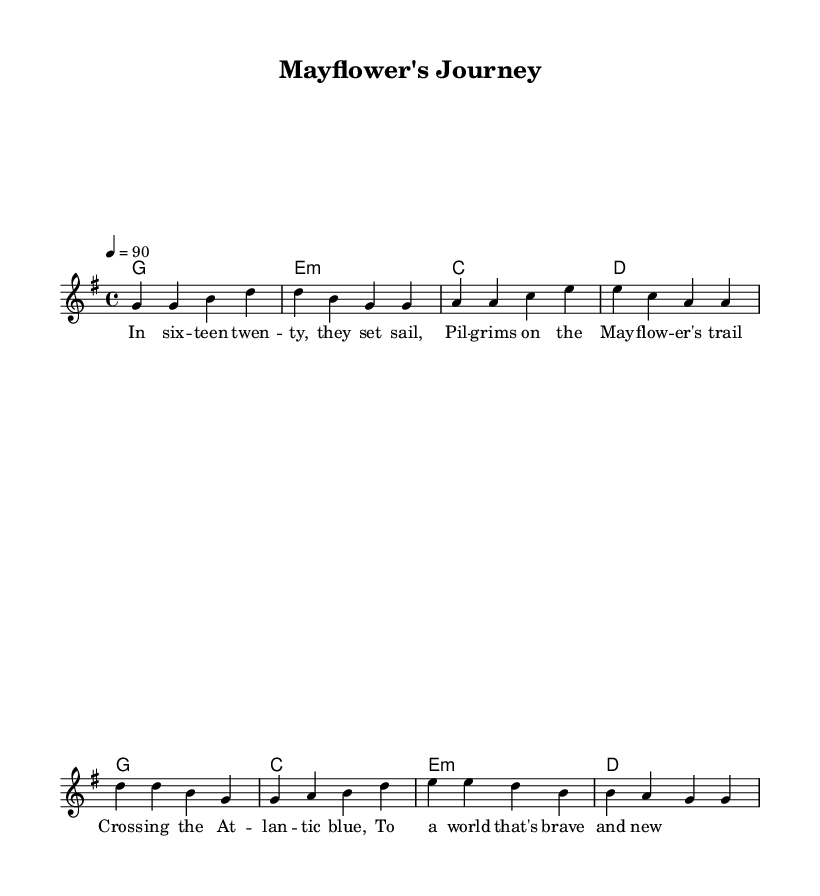What is the key signature of this music? The key signature is G major, which has one sharp (F#).
Answer: G major What is the time signature of this music? The time signature is 4/4, indicating four beats in each measure.
Answer: 4/4 What is the tempo marking for this piece? The tempo marking is 4 = 90, which means each quarter note is to be played at a speed of 90 beats per minute.
Answer: 90 How many measures are in the verse? The verse contains four measures, as indicated by the grouping of notes and chords.
Answer: Four In the chorus, what is the first note in the melody? The first note in the chorus is D, which starts the melodic line of this section.
Answer: D What chord follows the first line of the verse? The chord following the first line of the verse is E minor, as shown in the chord names below the melody.
Answer: E minor Why is the theme of this song relevant to historical voyages? The lyrics reference the Pilgrims' journey on the Mayflower, which is a significant historical voyage in American history.
Answer: Historical voyage 